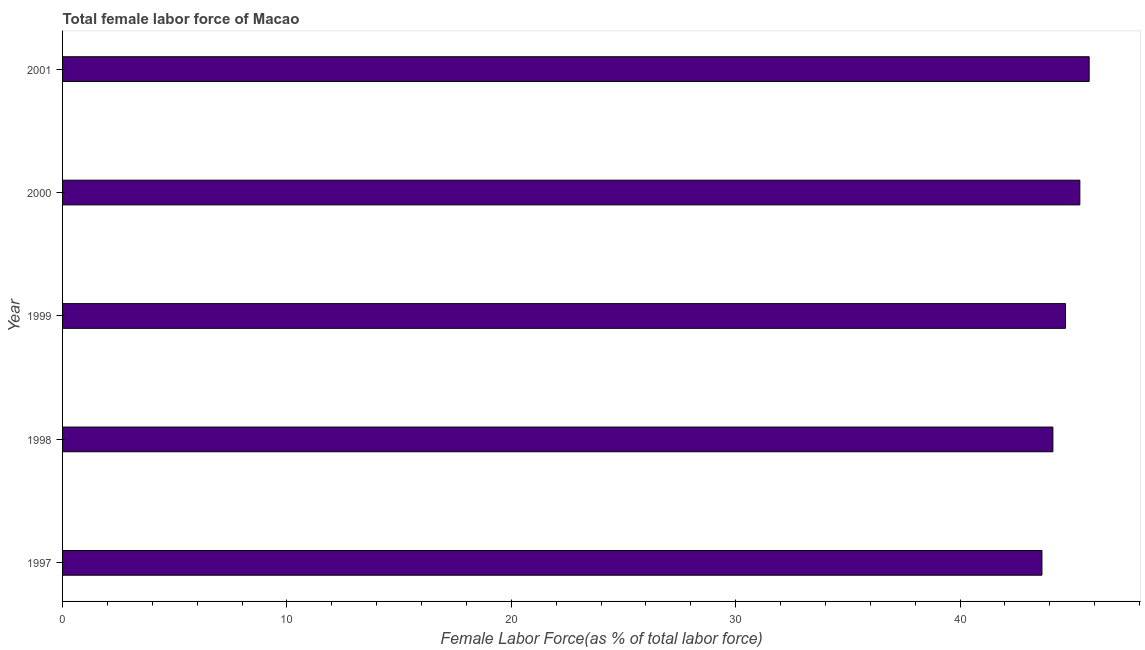What is the title of the graph?
Provide a succinct answer. Total female labor force of Macao. What is the label or title of the X-axis?
Make the answer very short. Female Labor Force(as % of total labor force). What is the total female labor force in 2001?
Ensure brevity in your answer.  45.76. Across all years, what is the maximum total female labor force?
Provide a succinct answer. 45.76. Across all years, what is the minimum total female labor force?
Give a very brief answer. 43.65. What is the sum of the total female labor force?
Ensure brevity in your answer.  223.59. What is the difference between the total female labor force in 1997 and 1998?
Provide a short and direct response. -0.49. What is the average total female labor force per year?
Offer a very short reply. 44.72. What is the median total female labor force?
Make the answer very short. 44.7. In how many years, is the total female labor force greater than 12 %?
Offer a very short reply. 5. Do a majority of the years between 1999 and 2001 (inclusive) have total female labor force greater than 6 %?
Offer a very short reply. Yes. What is the ratio of the total female labor force in 1999 to that in 2001?
Your answer should be very brief. 0.98. Is the difference between the total female labor force in 1999 and 2000 greater than the difference between any two years?
Give a very brief answer. No. What is the difference between the highest and the second highest total female labor force?
Your answer should be compact. 0.42. In how many years, is the total female labor force greater than the average total female labor force taken over all years?
Your answer should be compact. 2. How many bars are there?
Offer a very short reply. 5. Are all the bars in the graph horizontal?
Your answer should be compact. Yes. What is the difference between two consecutive major ticks on the X-axis?
Offer a very short reply. 10. Are the values on the major ticks of X-axis written in scientific E-notation?
Make the answer very short. No. What is the Female Labor Force(as % of total labor force) of 1997?
Make the answer very short. 43.65. What is the Female Labor Force(as % of total labor force) of 1998?
Provide a succinct answer. 44.14. What is the Female Labor Force(as % of total labor force) of 1999?
Offer a very short reply. 44.7. What is the Female Labor Force(as % of total labor force) of 2000?
Your response must be concise. 45.34. What is the Female Labor Force(as % of total labor force) in 2001?
Give a very brief answer. 45.76. What is the difference between the Female Labor Force(as % of total labor force) in 1997 and 1998?
Keep it short and to the point. -0.49. What is the difference between the Female Labor Force(as % of total labor force) in 1997 and 1999?
Keep it short and to the point. -1.05. What is the difference between the Female Labor Force(as % of total labor force) in 1997 and 2000?
Provide a short and direct response. -1.69. What is the difference between the Female Labor Force(as % of total labor force) in 1997 and 2001?
Provide a short and direct response. -2.1. What is the difference between the Female Labor Force(as % of total labor force) in 1998 and 1999?
Make the answer very short. -0.56. What is the difference between the Female Labor Force(as % of total labor force) in 1998 and 2000?
Make the answer very short. -1.2. What is the difference between the Female Labor Force(as % of total labor force) in 1998 and 2001?
Your answer should be very brief. -1.62. What is the difference between the Female Labor Force(as % of total labor force) in 1999 and 2000?
Your answer should be very brief. -0.64. What is the difference between the Female Labor Force(as % of total labor force) in 1999 and 2001?
Give a very brief answer. -1.05. What is the difference between the Female Labor Force(as % of total labor force) in 2000 and 2001?
Provide a short and direct response. -0.42. What is the ratio of the Female Labor Force(as % of total labor force) in 1997 to that in 1998?
Offer a very short reply. 0.99. What is the ratio of the Female Labor Force(as % of total labor force) in 1997 to that in 2001?
Offer a very short reply. 0.95. What is the ratio of the Female Labor Force(as % of total labor force) in 1998 to that in 1999?
Your answer should be compact. 0.99. What is the ratio of the Female Labor Force(as % of total labor force) in 1998 to that in 2000?
Your answer should be very brief. 0.97. What is the ratio of the Female Labor Force(as % of total labor force) in 2000 to that in 2001?
Your answer should be compact. 0.99. 